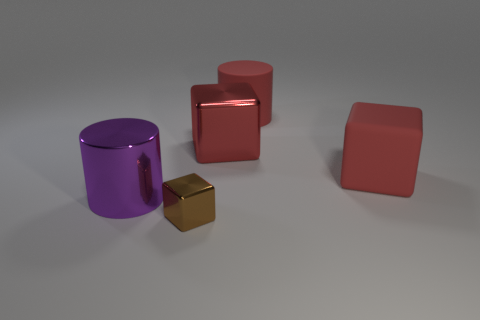Add 5 large blocks. How many objects exist? 10 Subtract all cubes. How many objects are left? 2 Add 1 small purple metallic spheres. How many small purple metallic spheres exist? 1 Subtract 0 yellow spheres. How many objects are left? 5 Subtract all red metallic cubes. Subtract all large red metallic things. How many objects are left? 3 Add 4 big purple things. How many big purple things are left? 5 